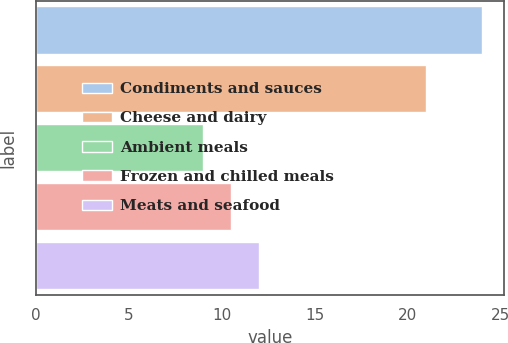<chart> <loc_0><loc_0><loc_500><loc_500><bar_chart><fcel>Condiments and sauces<fcel>Cheese and dairy<fcel>Ambient meals<fcel>Frozen and chilled meals<fcel>Meats and seafood<nl><fcel>24<fcel>21<fcel>9<fcel>10.5<fcel>12<nl></chart> 